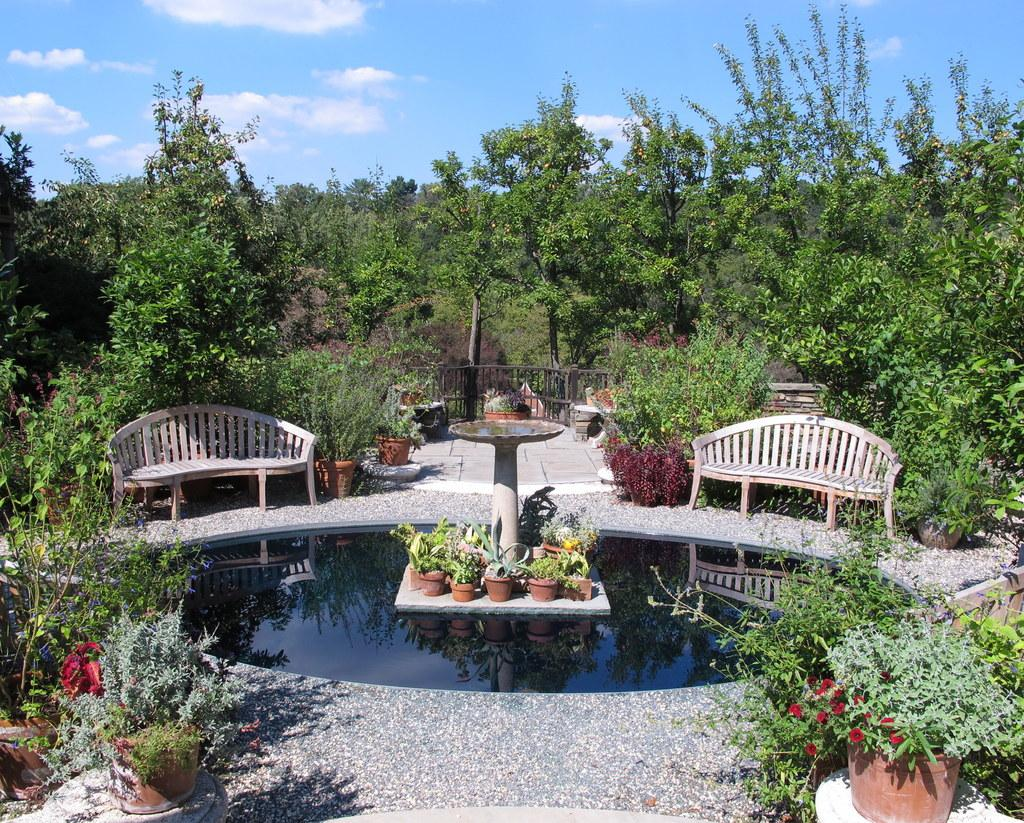What is the main feature in the image? There is a fountain in the image. What other objects can be seen in the image? There are clay pots in the image. What can be seen in the background of the image? There are trees, two wooden tables, and the sky visible in the background of the image. What is the condition of the sky in the image? Clouds are present in the sky. What type of badge is the zebra wearing while teaching in the image? There is no zebra or badge present in the image, and no teaching is taking place. 